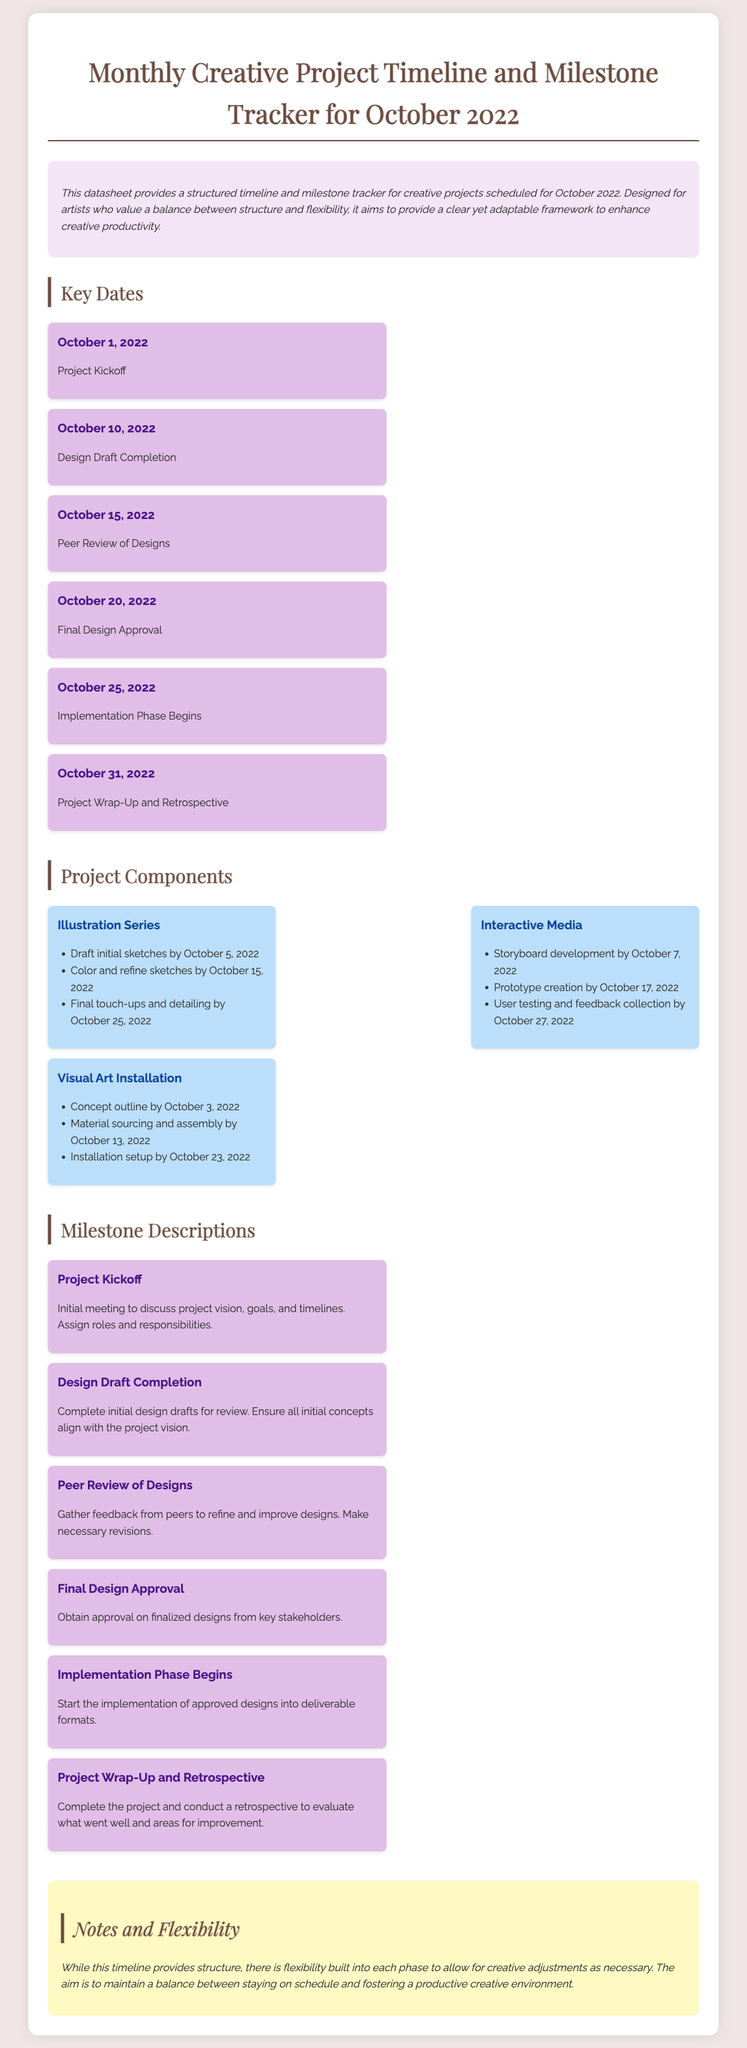What is the kickoff date for the project? The kickoff date is mentioned as the first milestone in the document.
Answer: October 1, 2022 What is the final milestone listed? The final milestone is the last event occurring in the timeline.
Answer: Project Wrap-Up and Retrospective How many project components are listed in the document? The project components section details three specific components.
Answer: Three What task is scheduled for October 15, 2022? The timeline specifies a milestone on this date regarding peer review.
Answer: Peer Review of Designs What is the aim of the document? The overview section summarizes the main purpose of creating this timeline for artists.
Answer: Provide a structured timeline and milestone tracker Which project component involves creating a storyboard? The specific project component dedicated to media creation contains this task.
Answer: Interactive Media What significant action occurs on October 25, 2022? This date marks the beginning of a particular phase of the project.
Answer: Implementation Phase Begins What is suggested about flexibility in the notes section? The notes indicate how the structure allows for adjustments during the project timeline.
Answer: Flexibility built into each phase 